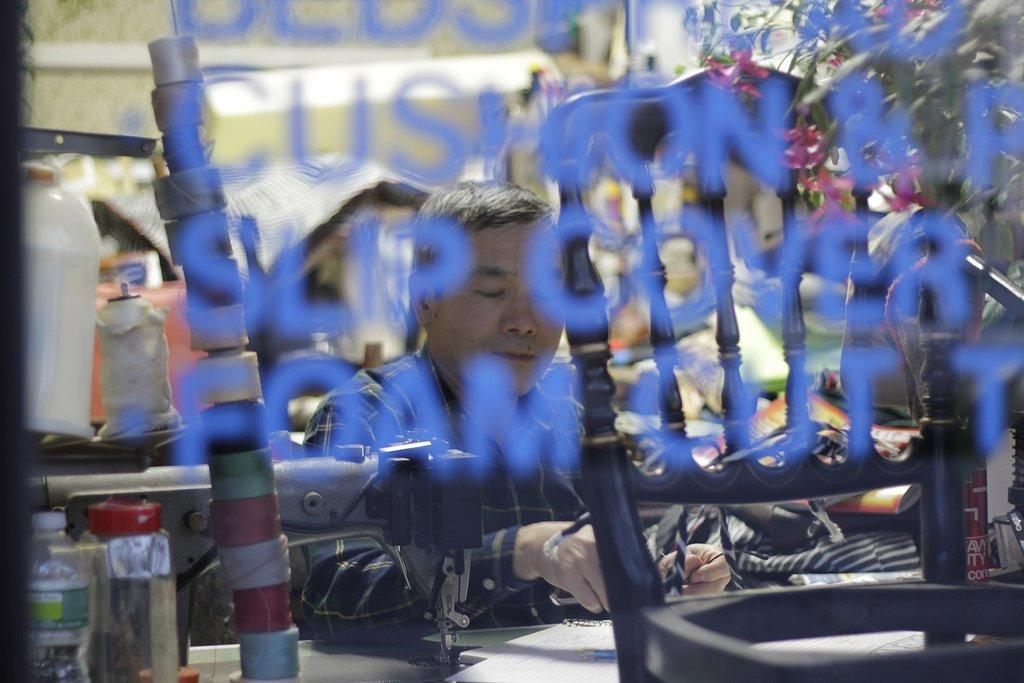What is the main object in the image that has text on it? There is a glass with some text in the image. What can be seen through the glass? A chairperson is visible through the glass. What type of machine is present in the image? There is a sewing machine in the image. What other items can be seen in the image? There are bottles in the image. Are there any other objects visible in the image? Yes, there are other objects visible in the image. What type of crime is being committed in the image? There is no indication of any crime being committed in the image. Can you see any ants in the image? There are no ants visible in the image. 